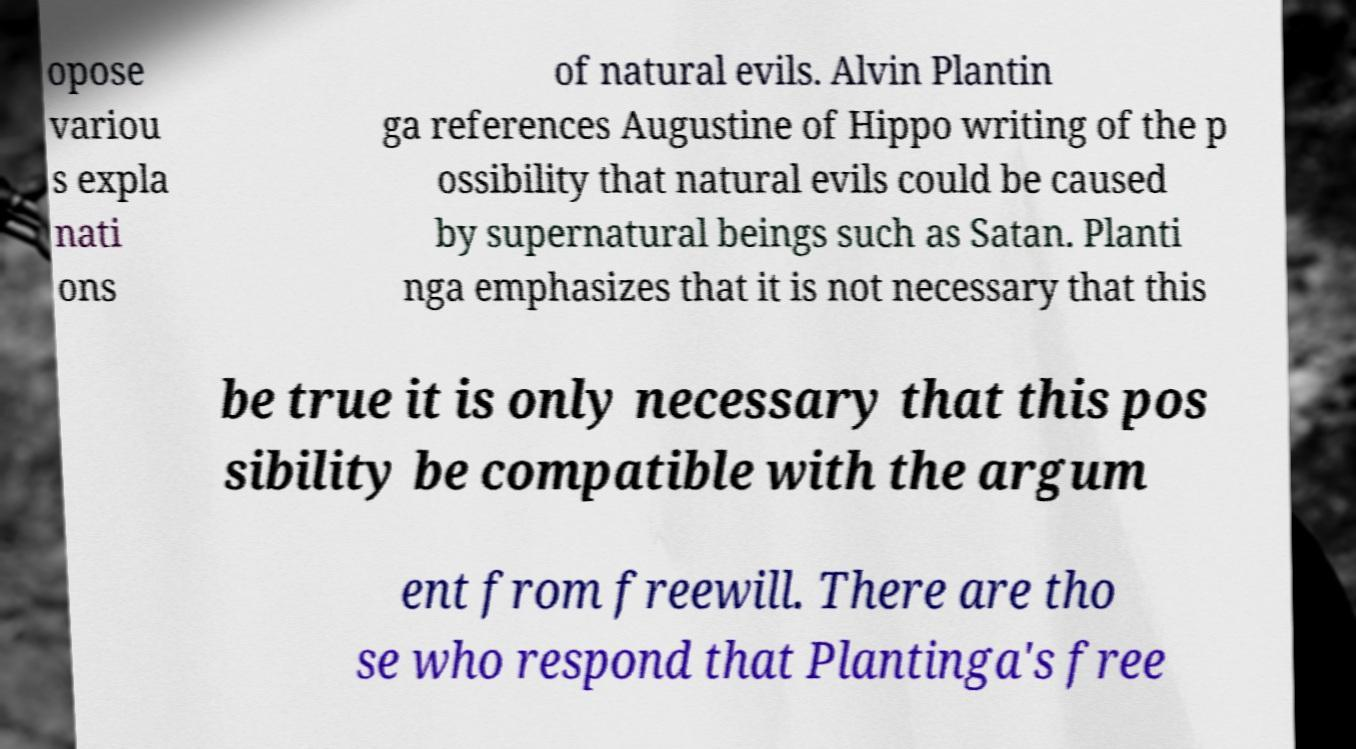Could you assist in decoding the text presented in this image and type it out clearly? opose variou s expla nati ons of natural evils. Alvin Plantin ga references Augustine of Hippo writing of the p ossibility that natural evils could be caused by supernatural beings such as Satan. Planti nga emphasizes that it is not necessary that this be true it is only necessary that this pos sibility be compatible with the argum ent from freewill. There are tho se who respond that Plantinga's free 